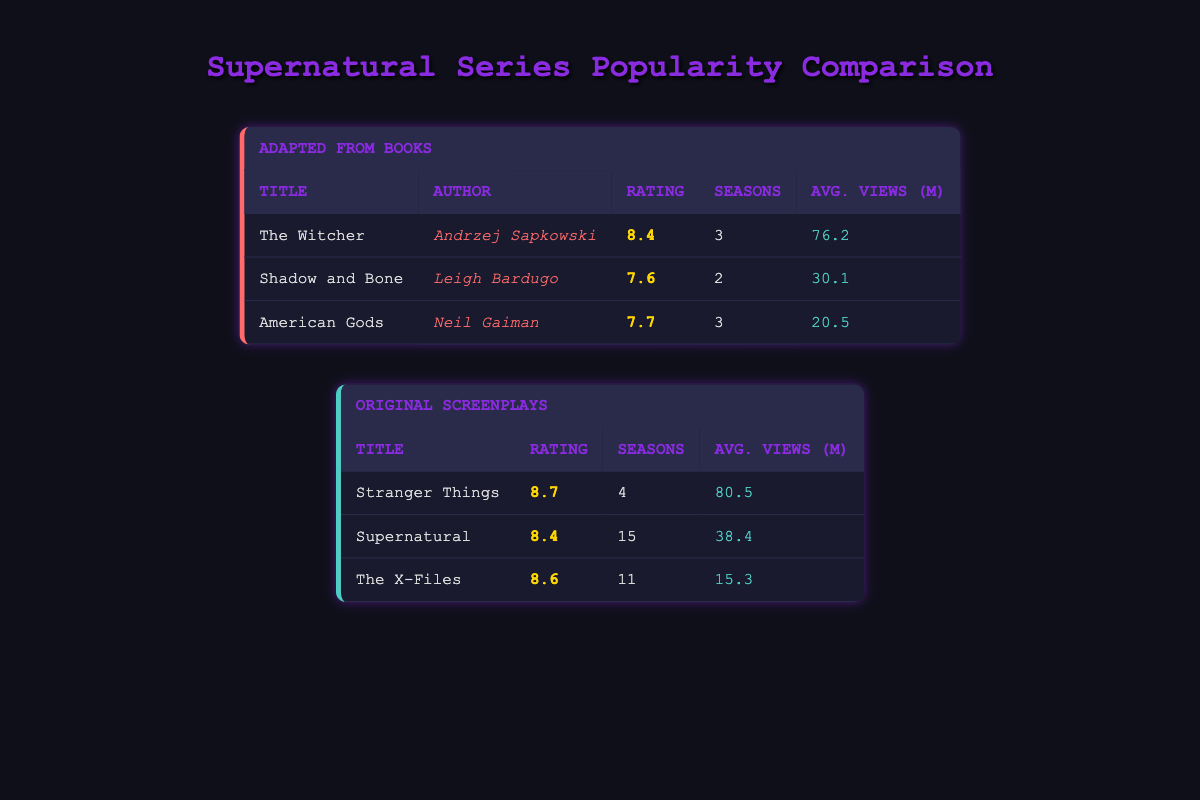What is the average rating of the series adapted from books? The ratings for the series adapted from books are 8.4 for The Witcher, 7.6 for Shadow and Bone, and 7.7 for American Gods. To find the average, add these ratings together: 8.4 + 7.6 + 7.7 = 23.7, then divide by the number of series (3): 23.7 / 3 = 7.9.
Answer: 7.9 Which original screenplay has the highest average views per episode? The average views per episode for the original screenplays are 80.5 for Stranger Things, 38.4 for Supernatural, and 15.3 for The X-Files. Since 80.5 is greater than both 38.4 and 15.3, Stranger Things has the highest views.
Answer: Stranger Things Is Shadow and Bone more popular than American Gods based on average views per episode? Shadow and Bone has 30.1 average views per episode, and American Gods has 20.5. Since 30.1 is greater than 20.5, Shadow and Bone is indeed more popular based on this metric.
Answer: Yes How many seasons does Supernatural have compared to The Witcher? Supernatural has 15 seasons as mentioned in the table, while The Witcher has 3 seasons. Therefore, Supernatural has 15 - 3 = 12 more seasons than The Witcher.
Answer: 12 What is the combined total of average views per episode for all series adapted from books? The average views are 76.2 for The Witcher, 30.1 for Shadow and Bone, and 20.5 for American Gods. Adding these gives: 76.2 + 30.1 + 20.5 = 126.8.
Answer: 126.8 Are there any series that were adapted from books with an average rating below 8.0? The series adapted from books include The Witcher (8.4), Shadow and Bone (7.6), and American Gods (7.7). Since Shadow and Bone has a rating of 7.6, which is below 8.0, the answer is yes.
Answer: Yes What is the difference in average ratings between the highest-rated original screenplay and the highest-rated series adapted from books? The highest rating for original screenplays is 8.7 for Stranger Things, and for adapted from books, it’s 8.4 for The Witcher. The difference is 8.7 - 8.4 = 0.3.
Answer: 0.3 Which series has the lowest average views per episode in both categories? The series with the lowest average views in adapted from books is American Gods with 20.5, and in original screenplays, it's The X-Files with 15.3. Between these, The X-Files has the lowest, at 15.3.
Answer: The X-Files How many total seasons do the series adapted from books have? The number of seasons are 3 for The Witcher, 2 for Shadow and Bone, and 3 for American Gods. Adding these gives: 3 + 2 + 3 = 8.
Answer: 8 